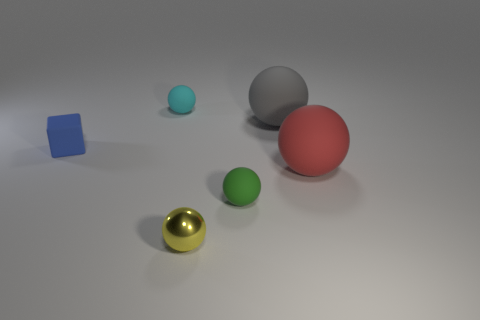What might be the relative sizes of these objects? From the perspective given in the image, we can infer relative sizes based on the apparent visual size difference and the shades indicating depth. The golden ball appears to be the smallest, perhaps due to proximity or actual size, followed by the blue cube and the green ball which are similar in size but slightly larger. The gray ball is a bit larger still, and the red ball appears to be the largest of all the spheres. The cyan ball's size is obscure, but it seems to be smaller than the red and similar in size to the green ball. 